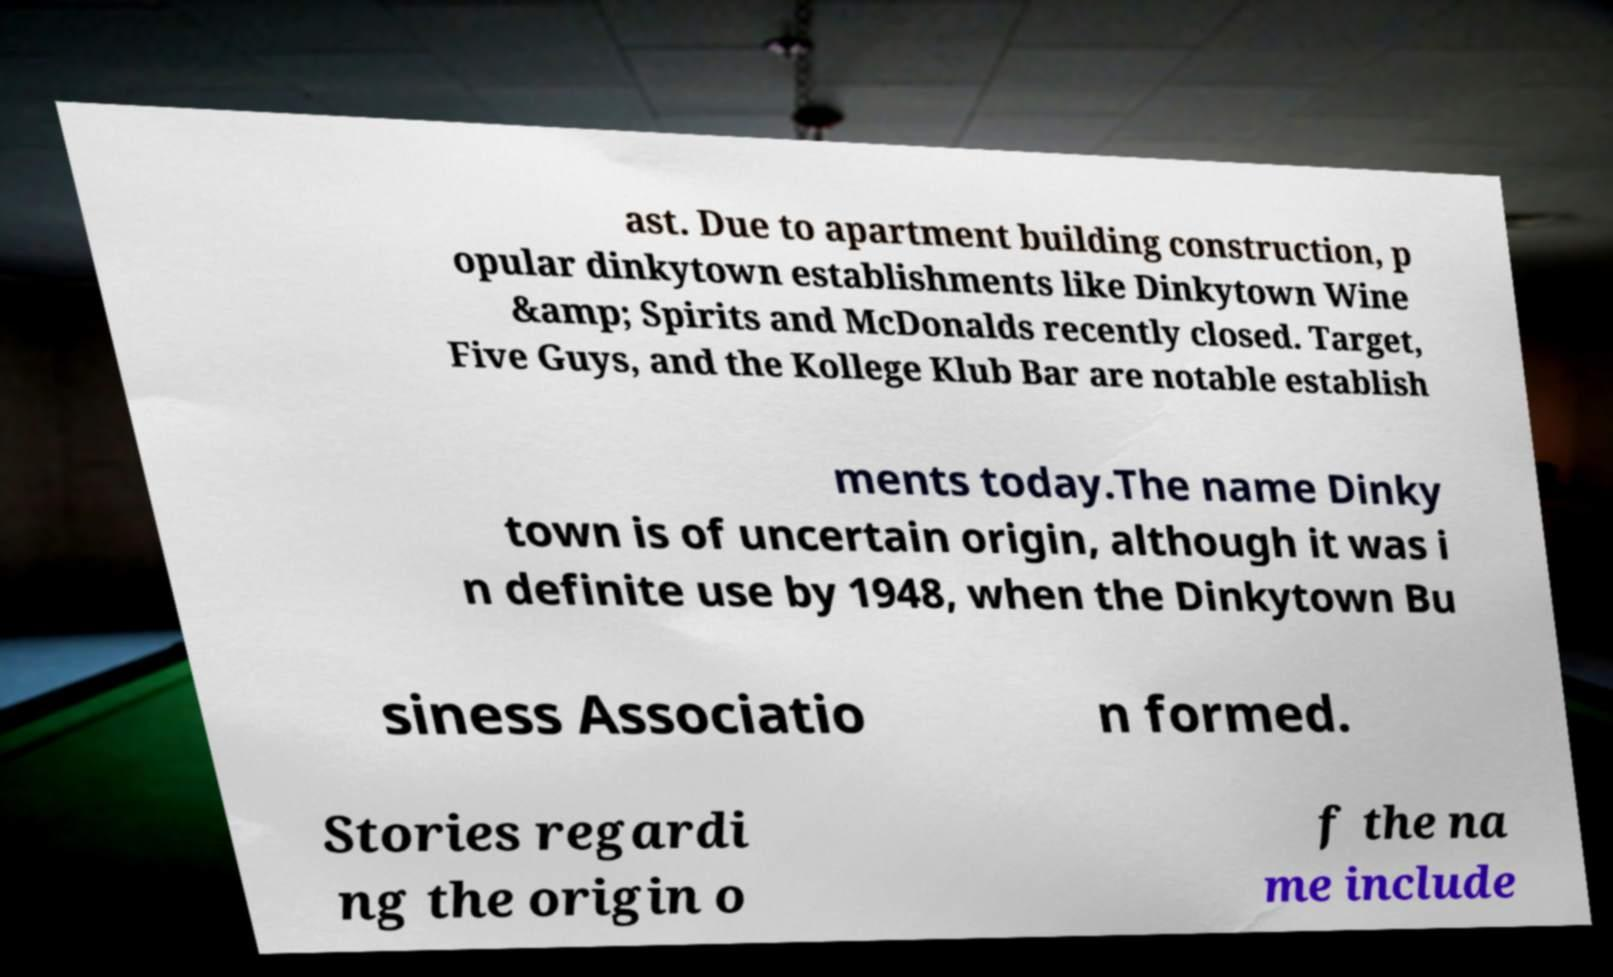Please read and relay the text visible in this image. What does it say? ast. Due to apartment building construction, p opular dinkytown establishments like Dinkytown Wine &amp; Spirits and McDonalds recently closed. Target, Five Guys, and the Kollege Klub Bar are notable establish ments today.The name Dinky town is of uncertain origin, although it was i n definite use by 1948, when the Dinkytown Bu siness Associatio n formed. Stories regardi ng the origin o f the na me include 